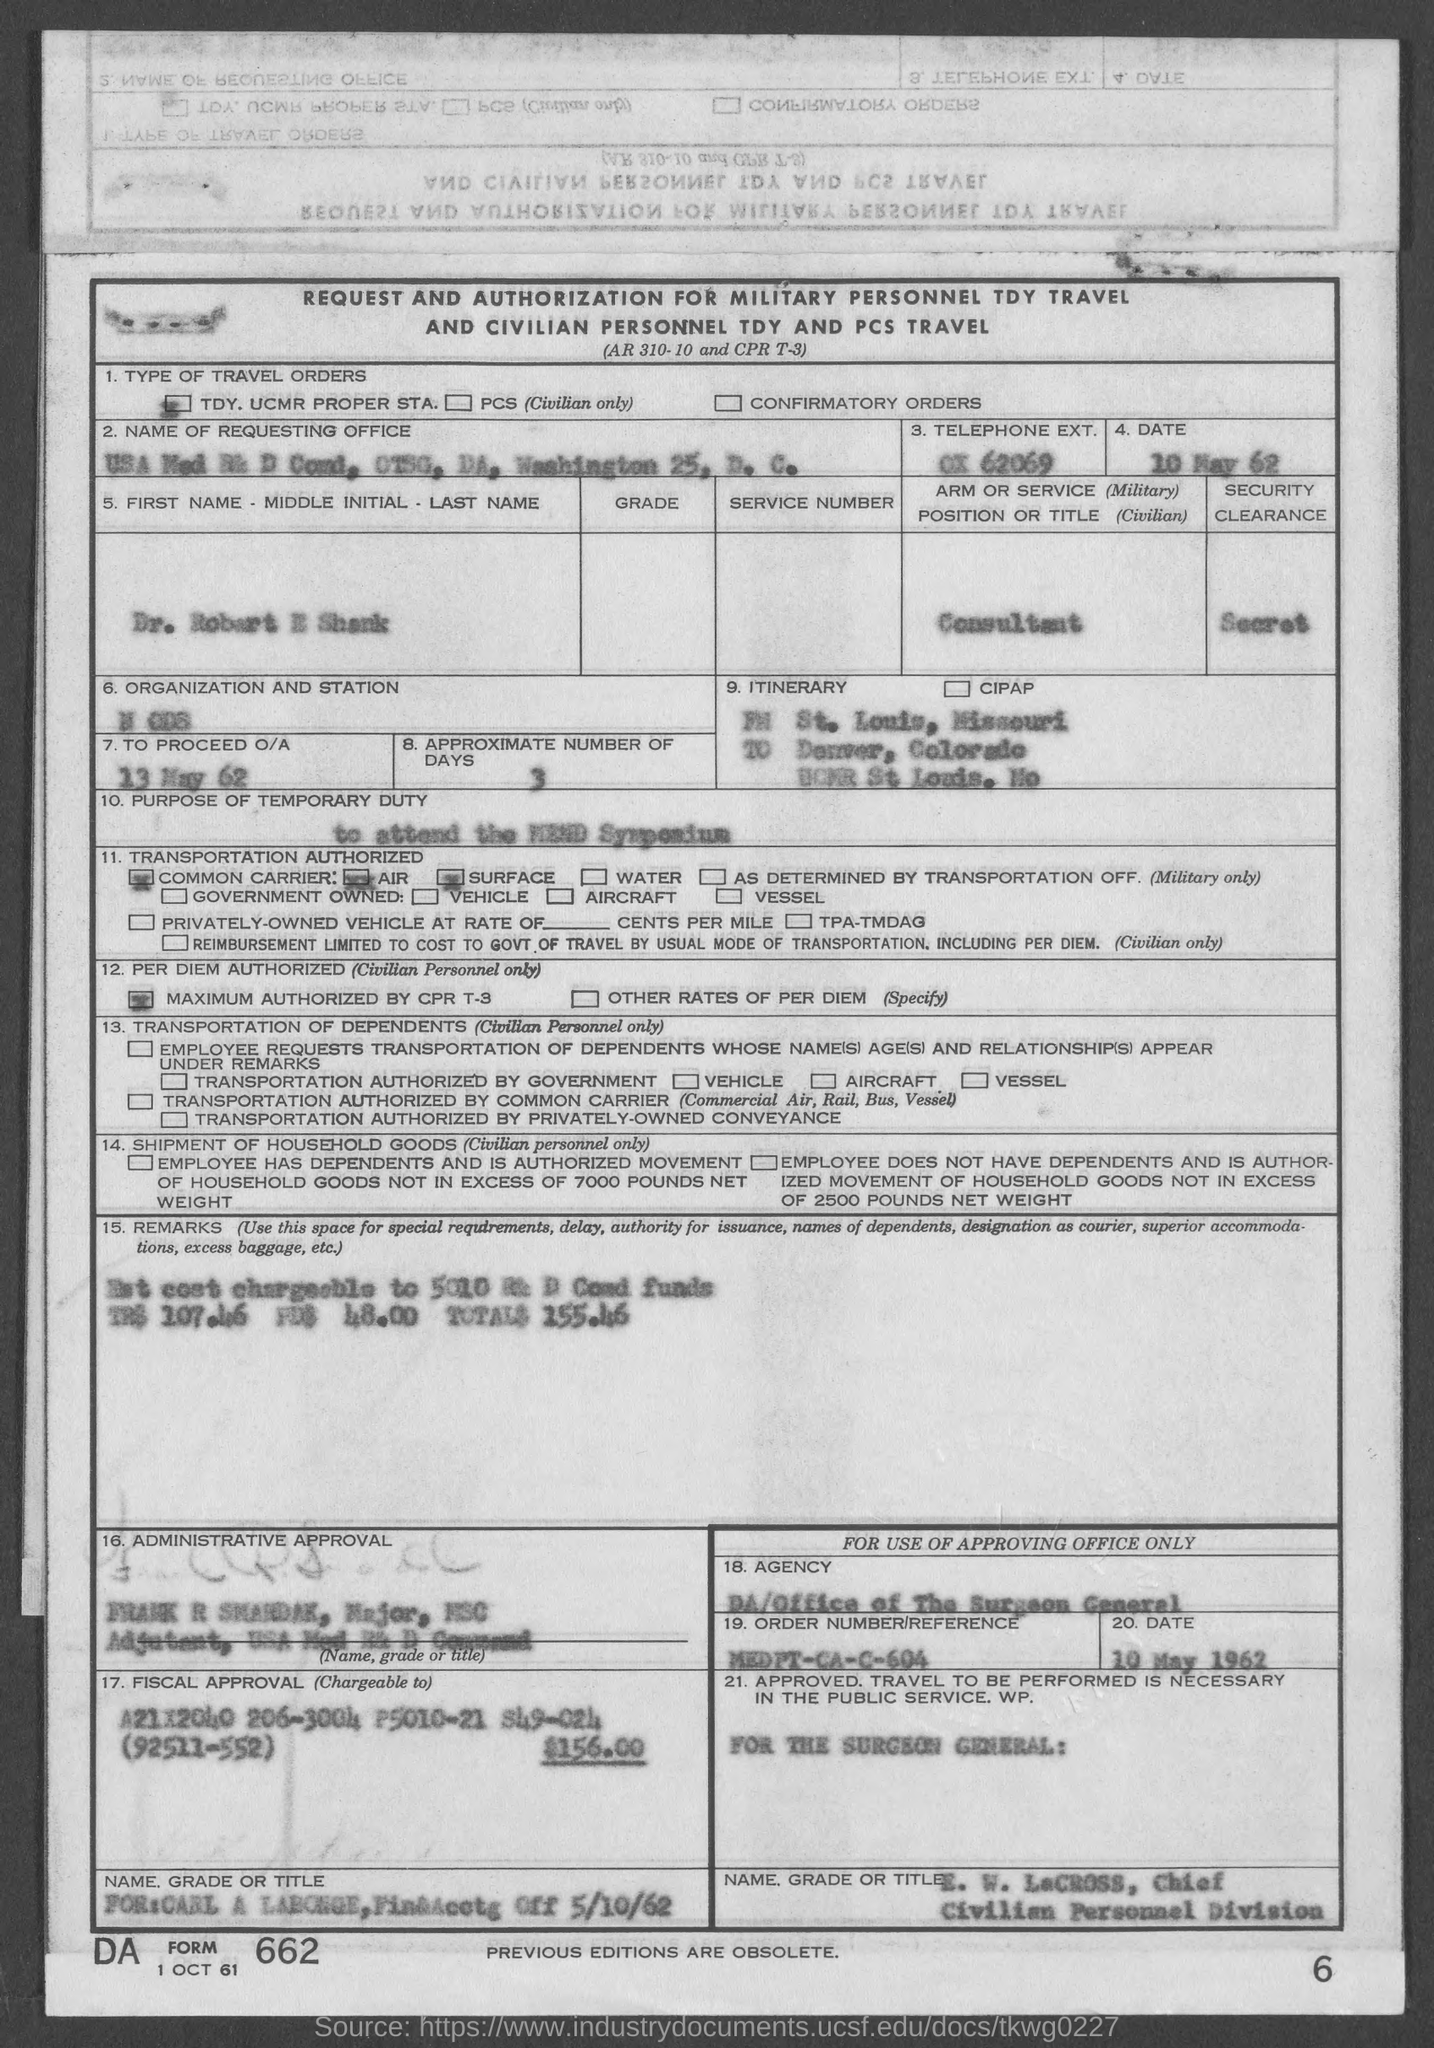Specify some key components in this picture. On the given page, it was mentioned that the date to proceed with Option/Action (O/A) as listed is May 13, 1962. The approximate number of days mentioned in the given page is 3. The position or title mentioned in the given form is that of a consultant. The security clearance mentioned in the given page is SECRET. The date mentioned on the given page is May 10, 1962. 